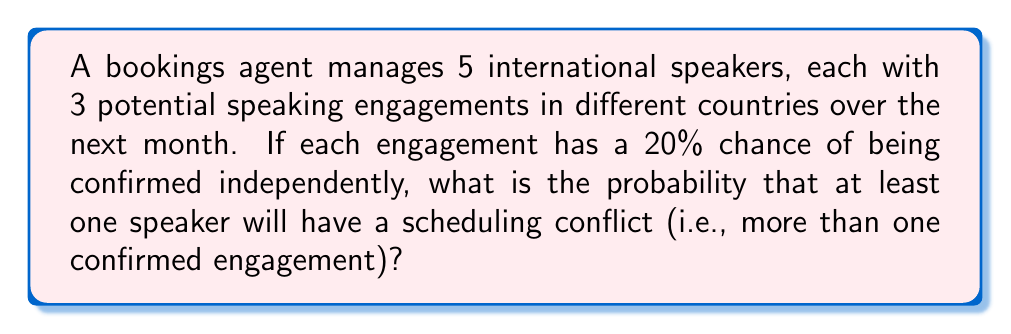Can you solve this math problem? Let's approach this step-by-step:

1) First, let's calculate the probability of a single speaker having a scheduling conflict.

   a) Probability of no conflict = Probability of 0 or 1 engagements confirmed
   b) Probability of 0 engagements: $P(0) = (0.8)^3 = 0.512$
   c) Probability of 1 engagement: $P(1) = \binom{3}{1}(0.2)(0.8)^2 = 3(0.2)(0.64) = 0.384$
   d) Probability of no conflict = $0.512 + 0.384 = 0.896$
   e) Probability of conflict for one speaker = $1 - 0.896 = 0.104$

2) Now, let's calculate the probability that no speakers have a conflict:
   $P(\text{no conflicts}) = (0.896)^5 = 0.5767$

3) Therefore, the probability that at least one speaker has a conflict is:
   $P(\text{at least one conflict}) = 1 - P(\text{no conflicts}) = 1 - 0.5767 = 0.4233$

Thus, there is approximately a 42.33% chance that at least one speaker will have a scheduling conflict.
Answer: $0.4233$ or $42.33\%$ 